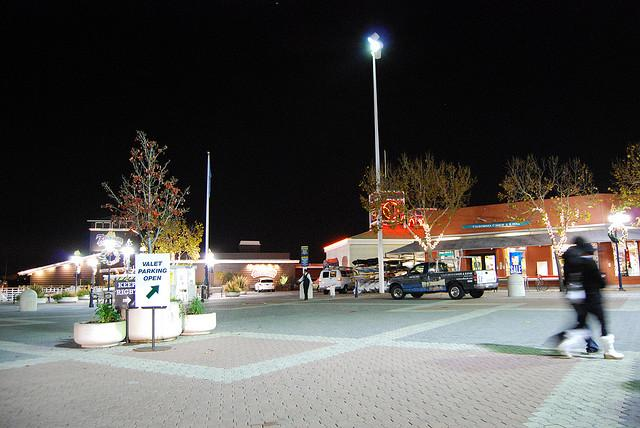What fast food restaurant is seen in the background?

Choices:
A) taco bell
B) mcdonald's
C) wendys
D) burger king mcdonald's 